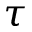Convert formula to latex. <formula><loc_0><loc_0><loc_500><loc_500>\tau</formula> 